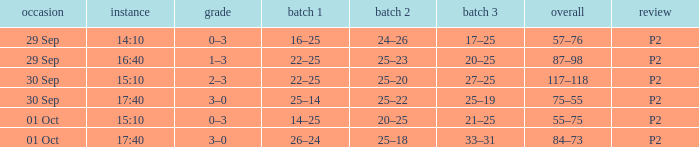For a date of 29 Sep and a time of 16:40, what is the corresponding Set 3? 20–25. 